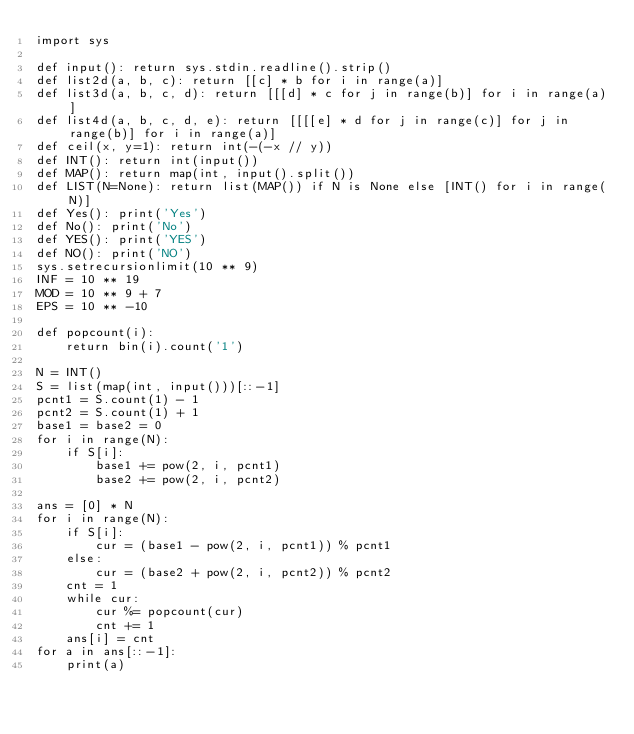<code> <loc_0><loc_0><loc_500><loc_500><_Python_>import sys

def input(): return sys.stdin.readline().strip()
def list2d(a, b, c): return [[c] * b for i in range(a)]
def list3d(a, b, c, d): return [[[d] * c for j in range(b)] for i in range(a)]
def list4d(a, b, c, d, e): return [[[[e] * d for j in range(c)] for j in range(b)] for i in range(a)]
def ceil(x, y=1): return int(-(-x // y))
def INT(): return int(input())
def MAP(): return map(int, input().split())
def LIST(N=None): return list(MAP()) if N is None else [INT() for i in range(N)]
def Yes(): print('Yes')
def No(): print('No')
def YES(): print('YES')
def NO(): print('NO')
sys.setrecursionlimit(10 ** 9)
INF = 10 ** 19
MOD = 10 ** 9 + 7
EPS = 10 ** -10

def popcount(i):
    return bin(i).count('1')

N = INT()
S = list(map(int, input()))[::-1]
pcnt1 = S.count(1) - 1
pcnt2 = S.count(1) + 1
base1 = base2 = 0
for i in range(N):
    if S[i]:
        base1 += pow(2, i, pcnt1)
        base2 += pow(2, i, pcnt2)

ans = [0] * N
for i in range(N):
    if S[i]:
        cur = (base1 - pow(2, i, pcnt1)) % pcnt1
    else:
        cur = (base2 + pow(2, i, pcnt2)) % pcnt2
    cnt = 1
    while cur:
        cur %= popcount(cur)
        cnt += 1
    ans[i] = cnt
for a in ans[::-1]:
    print(a)
</code> 